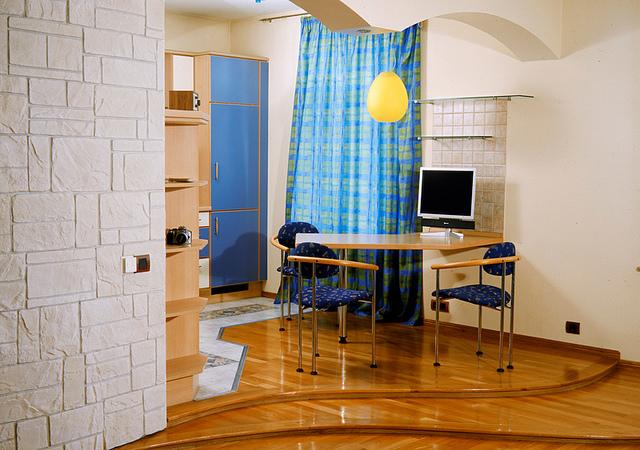What color is the light fixture?
Concise answer only. Yellow. What is the primary color scheme?
Answer briefly. Blue. Is the floor carpeted?
Quick response, please. No. 